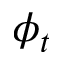<formula> <loc_0><loc_0><loc_500><loc_500>\phi _ { t }</formula> 